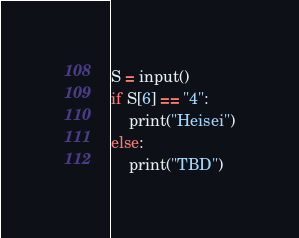Convert code to text. <code><loc_0><loc_0><loc_500><loc_500><_Python_>S = input()
if S[6] == "4":
    print("Heisei")
else:
    print("TBD")</code> 